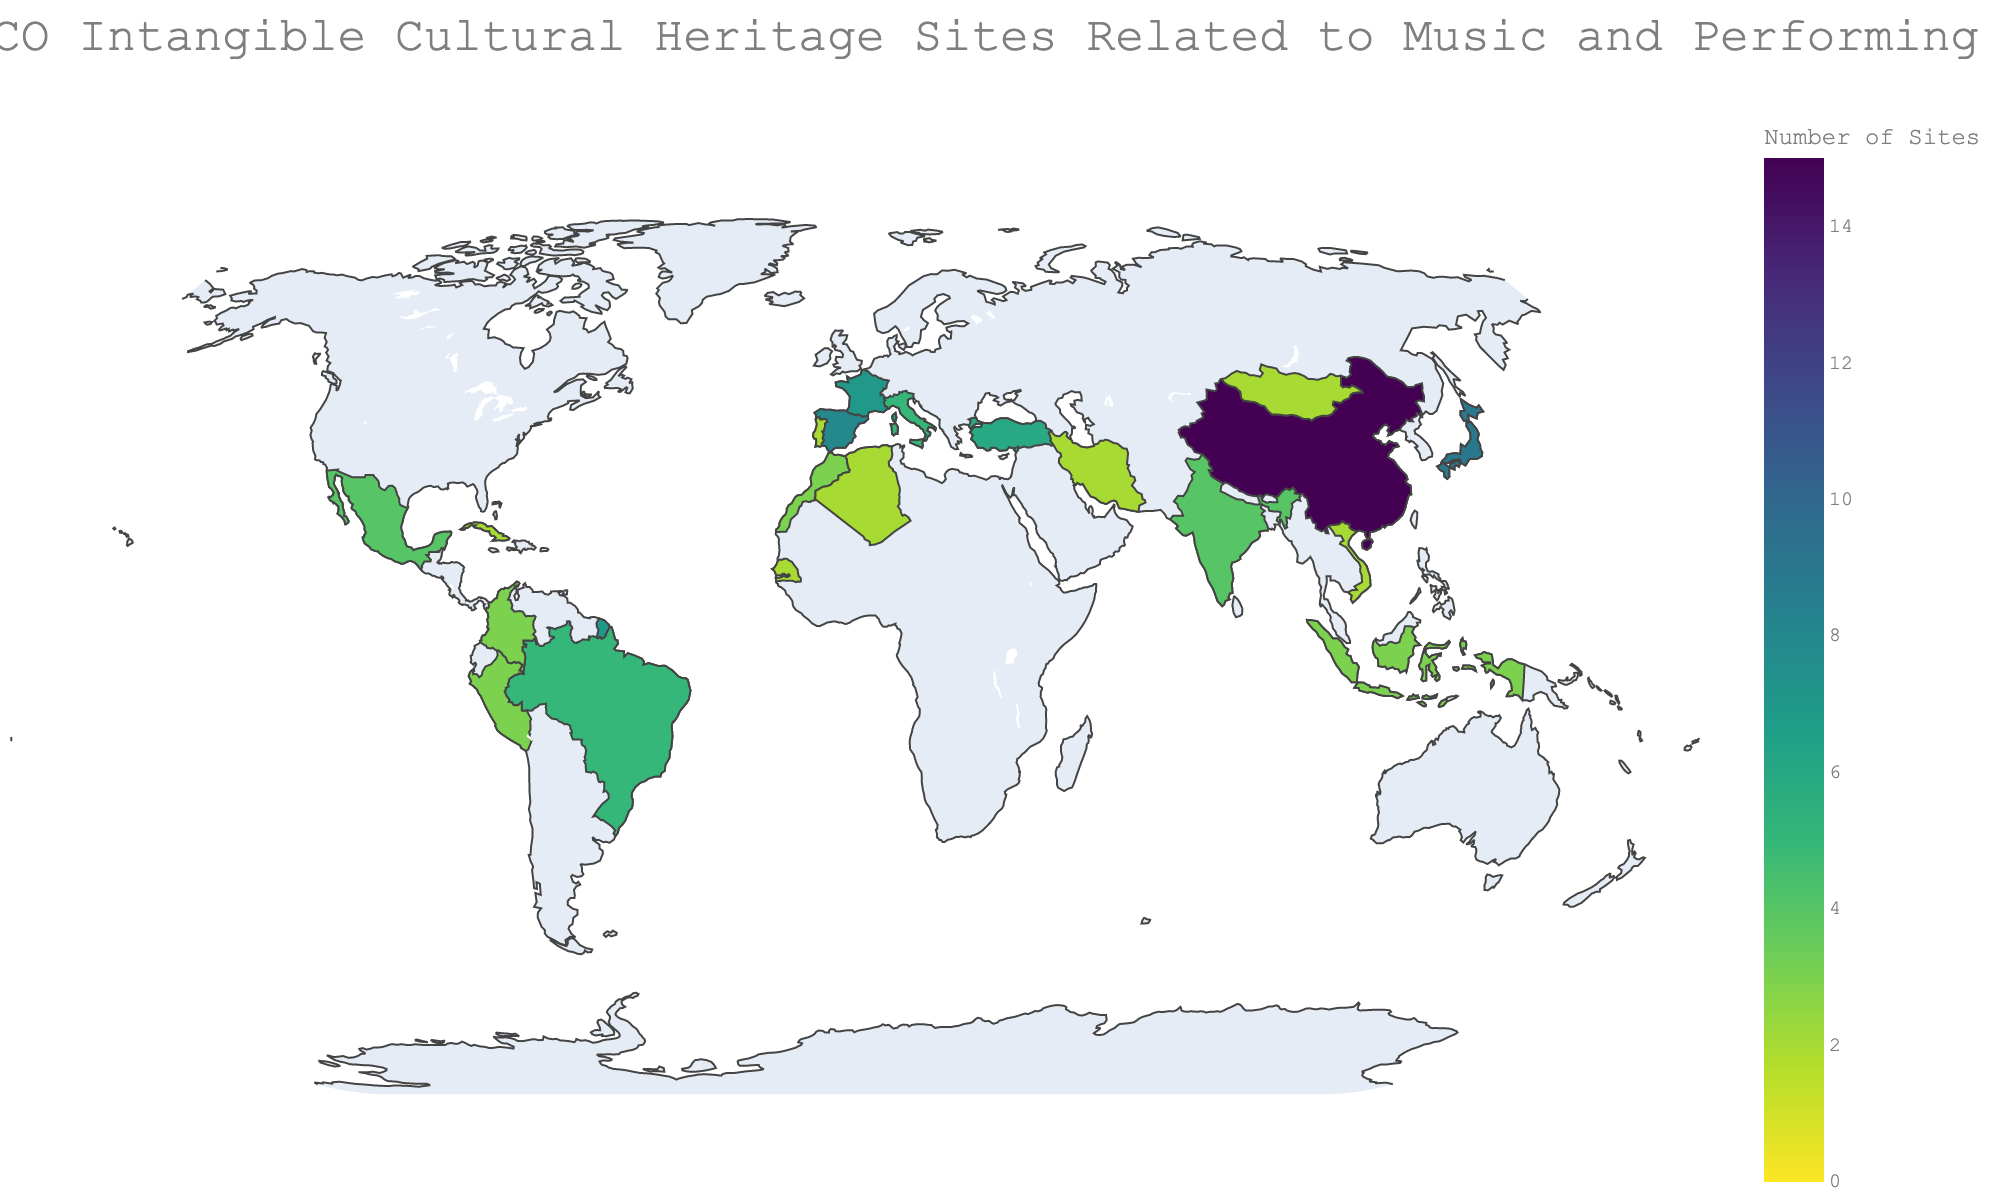Which country has the highest number of UNESCO Intangible Cultural Heritage sites related to music and performing arts? The figure indicates the concentration of these sites worldwide. By looking at the color intensity and the number labels, it's clear that China has the highest number, marked with the darkest color shade and the number 15.
Answer: China How many countries in Asia are represented in the figure? To determine the number of Asian countries, look at the countries listed and check their respective regions. The Asian countries listed are China, Japan, India, Indonesia, Iran, Mongolia, and Vietnam, totaling 7 countries.
Answer: 7 Which region has the least number of countries listed with UNESCO Intangible Cultural Heritage sites related to music and performing arts? By scanning through the regions and counting the distinct countries, the Caribbean has the least, with only one country, Cuba.
Answer: Caribbean How many countries have exactly two UNESCO Intangible Cultural Heritage sites related to music and performing arts? Looking at the counts next to each country, there are six countries with exactly two sites: Algeria, Cuba, Iran, Mongolia, Portugal, and Senegal.
Answer: 6 What is the total sum of UNESCO Intangible Cultural Heritage sites related to music and performing arts in South America? Sum the values of the South American countries listed: Brazil (5), Colombia (3), and Peru (3). The total sum is 5 + 3 + 3 = 11.
Answer: 11 Which country in Europe/Asia has more UNESCO Intangible Cultural Heritage sites related to music and performing arts than any country in South America? The country in Europe/Asia listed is Turkey with 6 sites, whereas the highest for any South American country is Brazil with 5. Thus, Turkey has more sites than any South American country.
Answer: Turkey What is the average number of UNESCO Intangible Cultural Heritage sites related to music and performing arts in African countries listed? Sum the values for African countries (Morocco: 3, Algeria: 2, Senegal: 2) and divide by the number of African countries (3). The average is (3+2+2)/3 = 7/3 ≈ 2.33.
Answer: 2.33 Which two countries in Europe have the same number of UNESCO Intangible Cultural Heritage sites related to music and performing arts? By comparing the numbers for each European country, Italy and Brazil both have 5 sites.
Answer: Italy and Brazil 